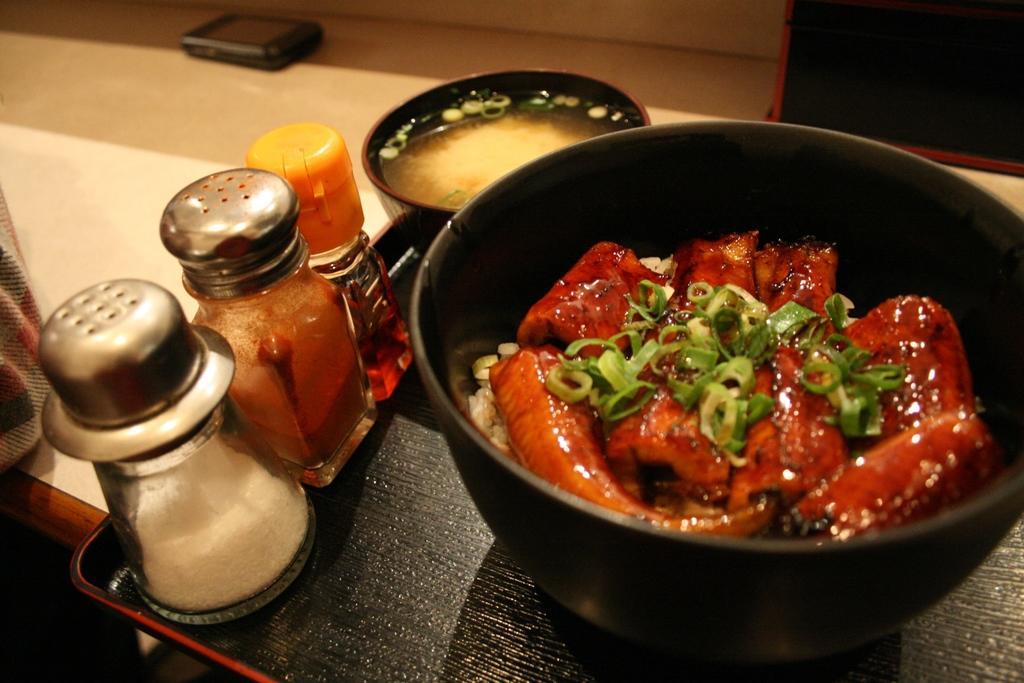In one or two sentences, can you explain what this image depicts? In this picture I can see on the right side there are food items in a black color bowl. On the left side there is a salt jar and other ingredients jars on a black color plate. 